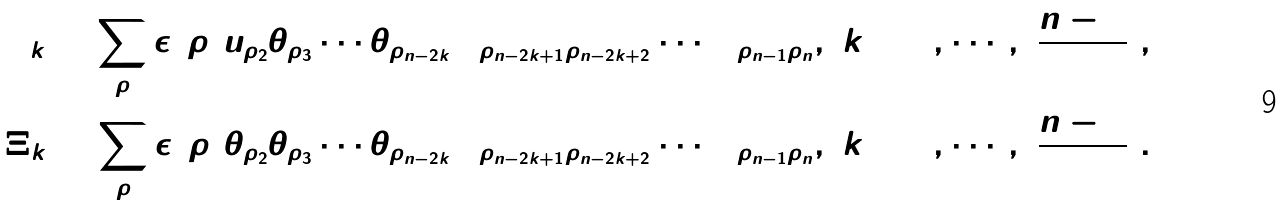Convert formula to latex. <formula><loc_0><loc_0><loc_500><loc_500>\Upsilon _ { k } = \sum _ { \rho } \epsilon ( \rho ) u _ { \rho _ { 2 } } \theta _ { \rho _ { 3 } } \cdots \theta _ { \rho _ { n - 2 k } } \Omega _ { \rho _ { n - 2 k + 1 } \rho _ { n - 2 k + 2 } } \cdots \Omega _ { \rho _ { n - 1 } \rho _ { n } } , \ k = 0 , \cdots , [ \frac { n - 2 } 2 ] , \\ \Xi _ { k } = \sum _ { \rho } \epsilon ( \rho ) \theta _ { \rho _ { 2 } } \theta _ { \rho _ { 3 } } \cdots \theta _ { \rho _ { n - 2 k } } \Omega _ { \rho _ { n - 2 k + 1 } \rho _ { n - 2 k + 2 } } \cdots \Omega _ { \rho _ { n - 1 } \rho _ { n } } , \ k = 0 , \cdots , [ \frac { n - 1 } 2 ] .</formula> 